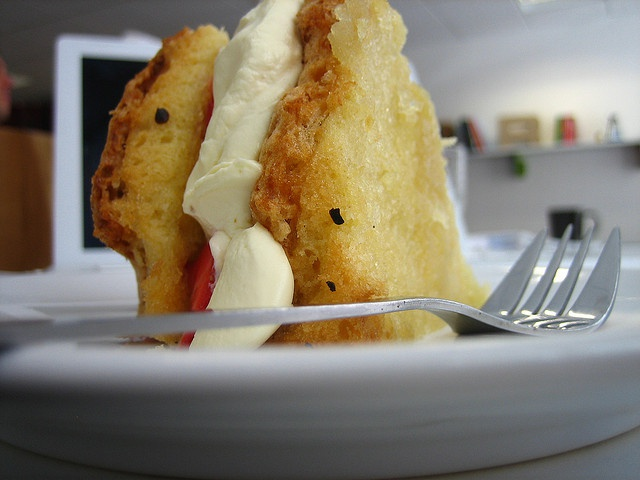Describe the objects in this image and their specific colors. I can see cake in black, olive, and tan tones, sandwich in black, olive, and tan tones, and fork in black, darkgray, gray, and lightgray tones in this image. 